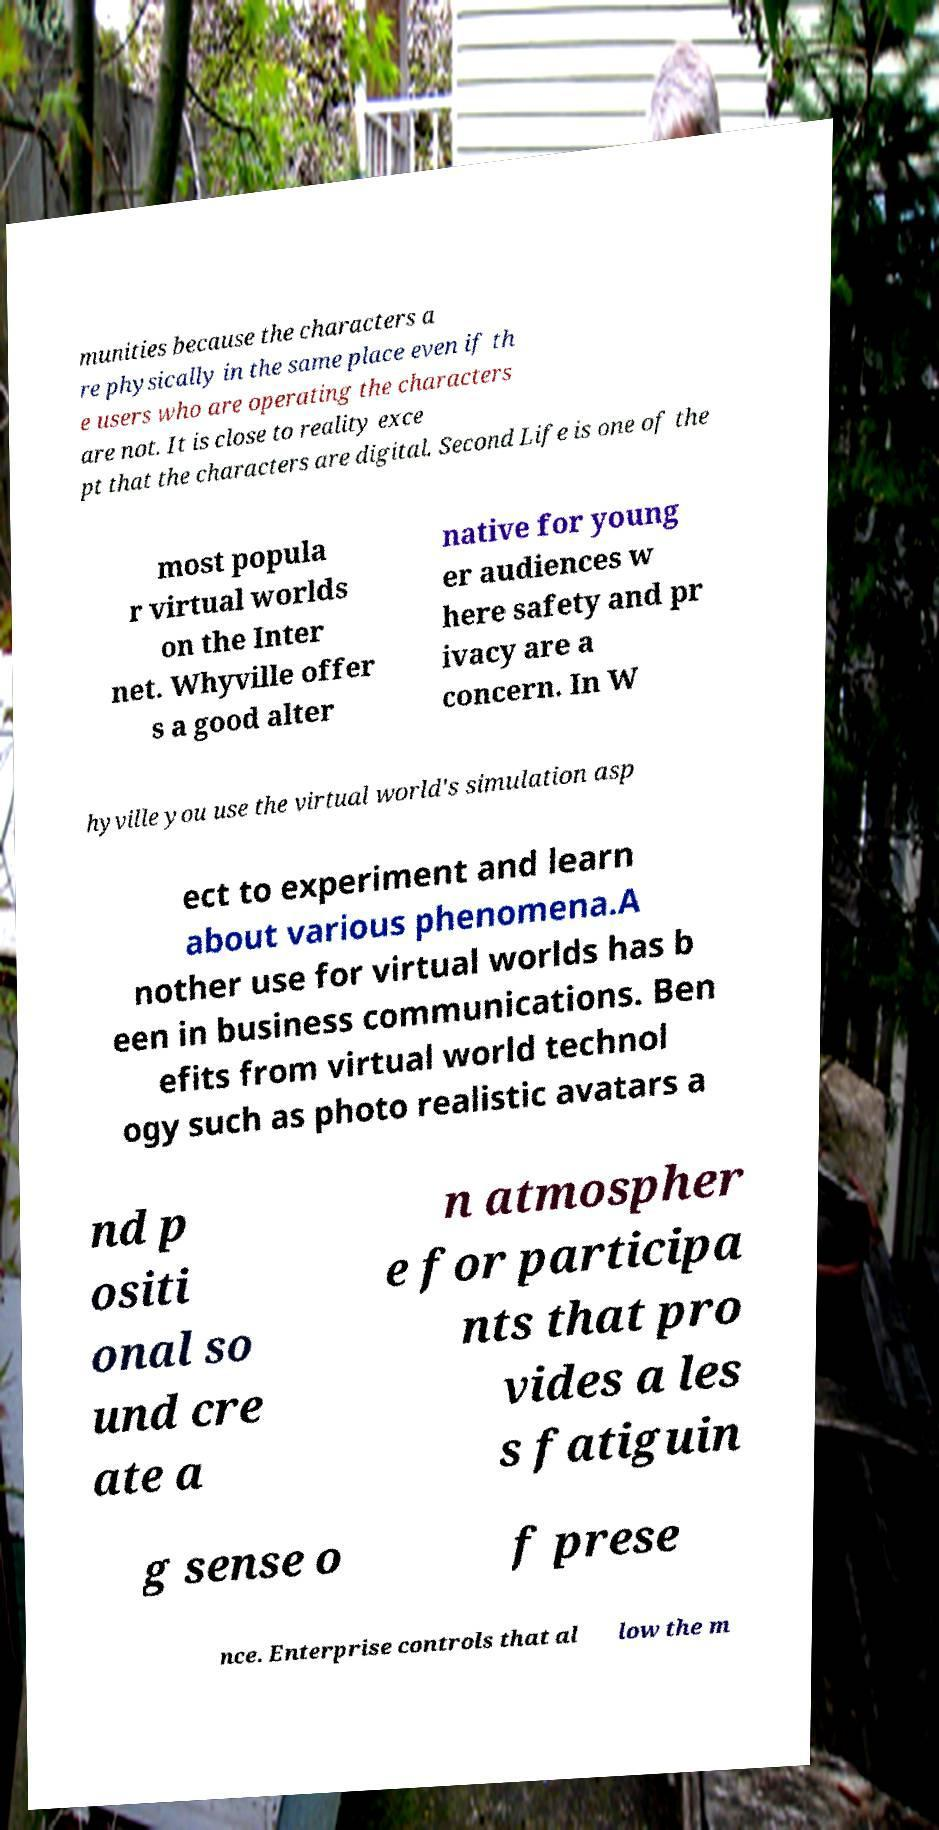For documentation purposes, I need the text within this image transcribed. Could you provide that? munities because the characters a re physically in the same place even if th e users who are operating the characters are not. It is close to reality exce pt that the characters are digital. Second Life is one of the most popula r virtual worlds on the Inter net. Whyville offer s a good alter native for young er audiences w here safety and pr ivacy are a concern. In W hyville you use the virtual world's simulation asp ect to experiment and learn about various phenomena.A nother use for virtual worlds has b een in business communications. Ben efits from virtual world technol ogy such as photo realistic avatars a nd p ositi onal so und cre ate a n atmospher e for participa nts that pro vides a les s fatiguin g sense o f prese nce. Enterprise controls that al low the m 